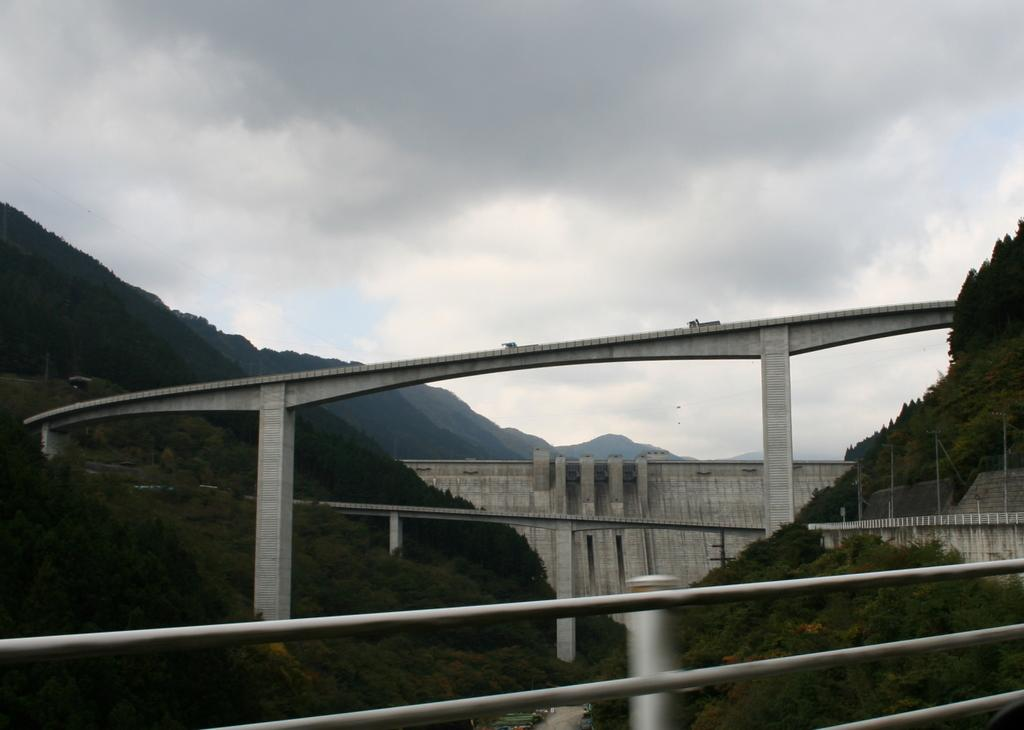What structure is visible in the image? There is a bridge in the image. What is happening on the bridge? There are vehicles moving on the bridge. What can be seen in the background of the image? There are two mountains in the image, and they are covered with trees. How would you describe the sky in the image? The sky is cloudy in the image. How many rabbits can be seen hopping on the bridge in the image? There are no rabbits visible in the image; the bridge has vehicles moving on it. Can you tell me the name of the representative standing near the mountains in the image? There is no representative present in the image; it only features a bridge, vehicles, mountains, and trees. 